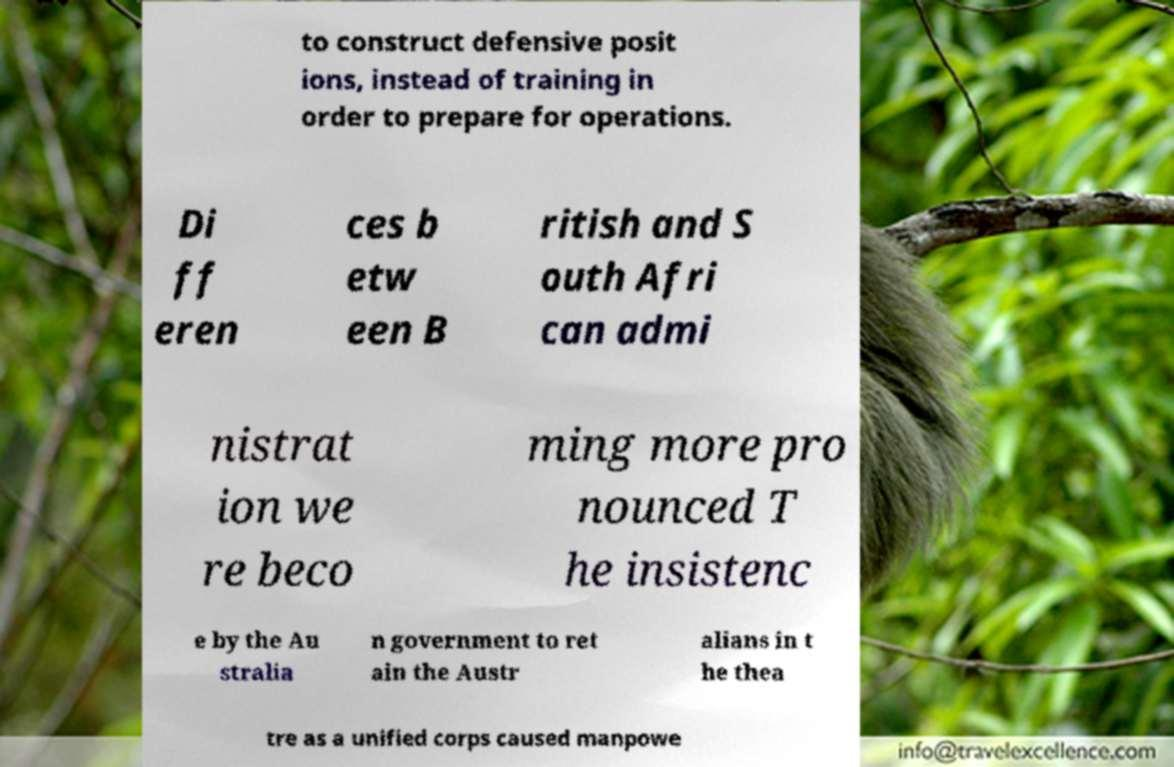Can you read and provide the text displayed in the image?This photo seems to have some interesting text. Can you extract and type it out for me? to construct defensive posit ions, instead of training in order to prepare for operations. Di ff eren ces b etw een B ritish and S outh Afri can admi nistrat ion we re beco ming more pro nounced T he insistenc e by the Au stralia n government to ret ain the Austr alians in t he thea tre as a unified corps caused manpowe 